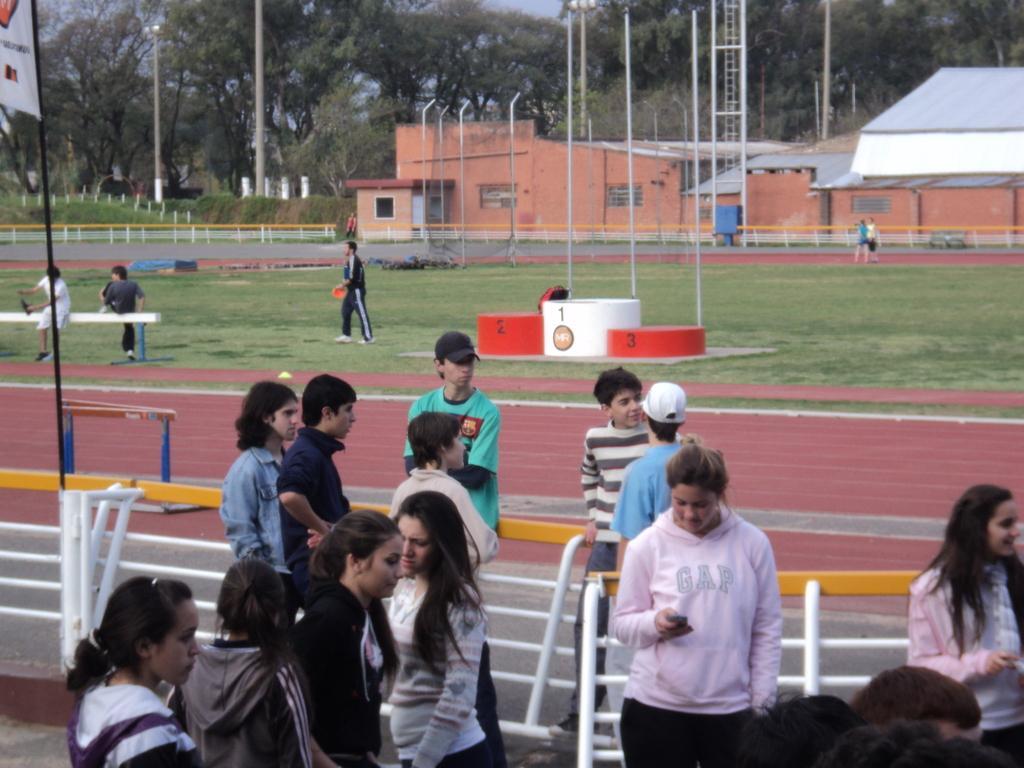In one or two sentences, can you explain what this image depicts? In this image, we can see people standing and some are wearing caps and some are holding objects in their hands. In the background, there are trees, sheds, poles, lights, railings, rods, stones and we can see a flag. At the bottom, there is ground. 